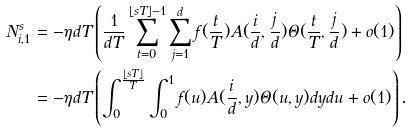Convert formula to latex. <formula><loc_0><loc_0><loc_500><loc_500>N _ { i , 1 } ^ { s } & = - \eta d T \left ( \frac { 1 } { d T } \sum _ { t = 0 } ^ { \lfloor s T \rfloor - 1 } \sum _ { j = 1 } ^ { d } f ( \frac { t } { T } ) A ( \frac { i } { d } , \frac { j } { d } ) \Theta ( \frac { t } { T } , \frac { j } { d } ) + o ( 1 ) \right ) \\ & = - \eta d T \left ( \int _ { 0 } ^ { \frac { \lfloor s T \rfloor } { T } } \int _ { 0 } ^ { 1 } f ( u ) A ( \frac { i } { d } , y ) \Theta ( u , y ) d y d u + o ( 1 ) \right ) .</formula> 